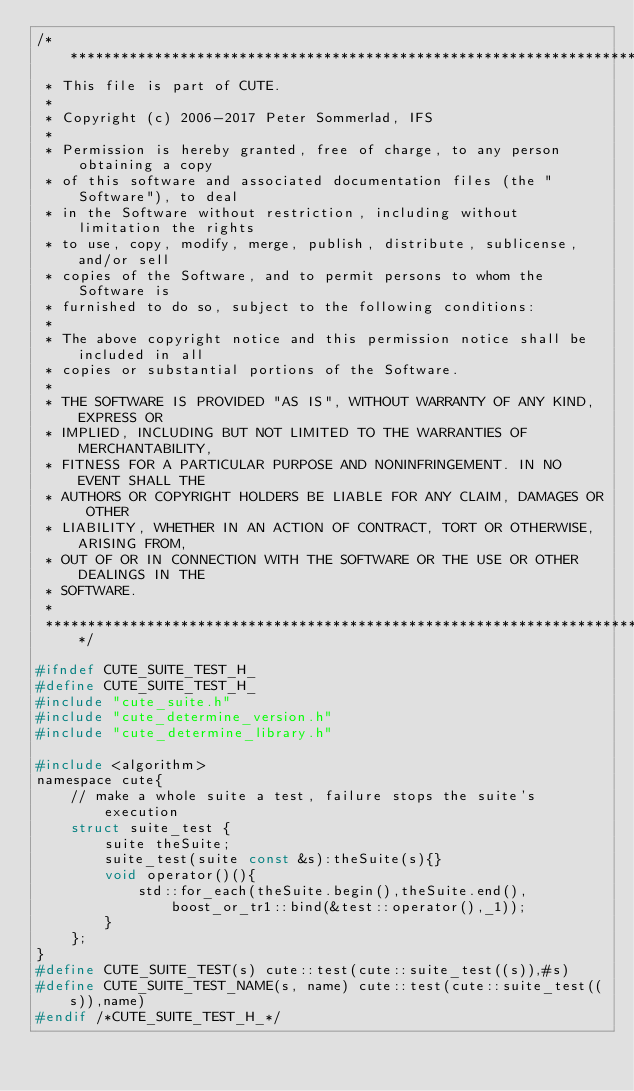Convert code to text. <code><loc_0><loc_0><loc_500><loc_500><_C_>/*********************************************************************************
 * This file is part of CUTE.
 *
 * Copyright (c) 2006-2017 Peter Sommerlad, IFS
 *
 * Permission is hereby granted, free of charge, to any person obtaining a copy
 * of this software and associated documentation files (the "Software"), to deal
 * in the Software without restriction, including without limitation the rights
 * to use, copy, modify, merge, publish, distribute, sublicense, and/or sell
 * copies of the Software, and to permit persons to whom the Software is
 * furnished to do so, subject to the following conditions:
 *
 * The above copyright notice and this permission notice shall be included in all
 * copies or substantial portions of the Software.
 *
 * THE SOFTWARE IS PROVIDED "AS IS", WITHOUT WARRANTY OF ANY KIND, EXPRESS OR
 * IMPLIED, INCLUDING BUT NOT LIMITED TO THE WARRANTIES OF MERCHANTABILITY,
 * FITNESS FOR A PARTICULAR PURPOSE AND NONINFRINGEMENT. IN NO EVENT SHALL THE
 * AUTHORS OR COPYRIGHT HOLDERS BE LIABLE FOR ANY CLAIM, DAMAGES OR OTHER
 * LIABILITY, WHETHER IN AN ACTION OF CONTRACT, TORT OR OTHERWISE, ARISING FROM,
 * OUT OF OR IN CONNECTION WITH THE SOFTWARE OR THE USE OR OTHER DEALINGS IN THE
 * SOFTWARE.
 *
 *********************************************************************************/

#ifndef CUTE_SUITE_TEST_H_
#define CUTE_SUITE_TEST_H_
#include "cute_suite.h"
#include "cute_determine_version.h"
#include "cute_determine_library.h"

#include <algorithm>
namespace cute{
	// make a whole suite a test, failure stops the suite's execution
	struct suite_test {
		suite theSuite;
		suite_test(suite const &s):theSuite(s){}
		void operator()(){
			std::for_each(theSuite.begin(),theSuite.end(),boost_or_tr1::bind(&test::operator(),_1));
		}
	};
}
#define CUTE_SUITE_TEST(s) cute::test(cute::suite_test((s)),#s)
#define CUTE_SUITE_TEST_NAME(s, name) cute::test(cute::suite_test((s)),name)
#endif /*CUTE_SUITE_TEST_H_*/
</code> 